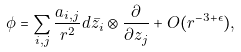Convert formula to latex. <formula><loc_0><loc_0><loc_500><loc_500>\phi = \sum _ { i , j } \frac { a _ { i , j } } { r ^ { 2 } } d \bar { z _ { i } } \otimes \frac { \partial } { \partial z _ { j } } + O ( r ^ { - 3 + \epsilon } ) ,</formula> 